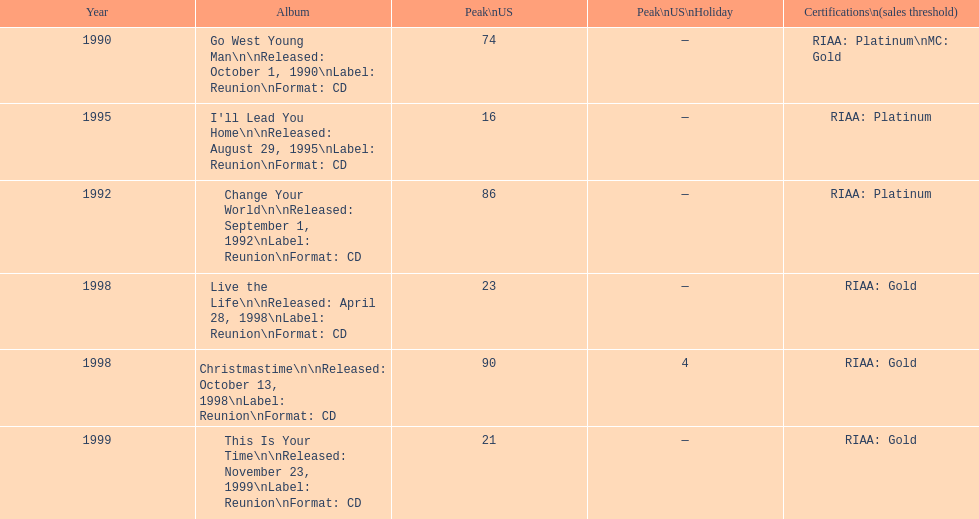What is the number of michael w smith albums that made it to the top 25 of the charts? 3. 